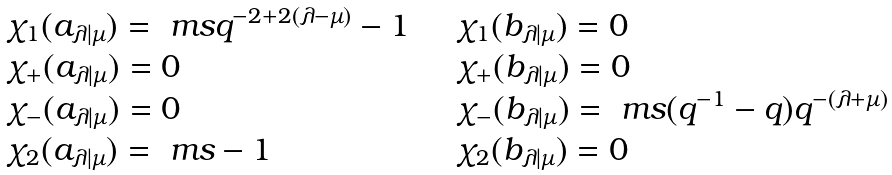<formula> <loc_0><loc_0><loc_500><loc_500>\begin{array} { l l } \chi _ { 1 } ( a _ { \lambda | \mu } ) = \ m s q ^ { - 2 + 2 ( \lambda - \mu ) } - 1 & \quad \chi _ { 1 } ( b _ { \lambda | \mu } ) = 0 \\ \chi _ { + } ( a _ { \lambda | \mu } ) = 0 & \quad \chi _ { + } ( b _ { \lambda | \mu } ) = 0 \\ \chi _ { - } ( a _ { \lambda | \mu } ) = 0 & \quad \chi _ { - } ( b _ { \lambda | \mu } ) = \ m s ( q ^ { - 1 } - q ) q ^ { - ( \lambda + \mu ) } \\ \chi _ { 2 } ( a _ { \lambda | \mu } ) = \ m s - 1 & \quad \chi _ { 2 } ( b _ { \lambda | \mu } ) = 0 \end{array}</formula> 